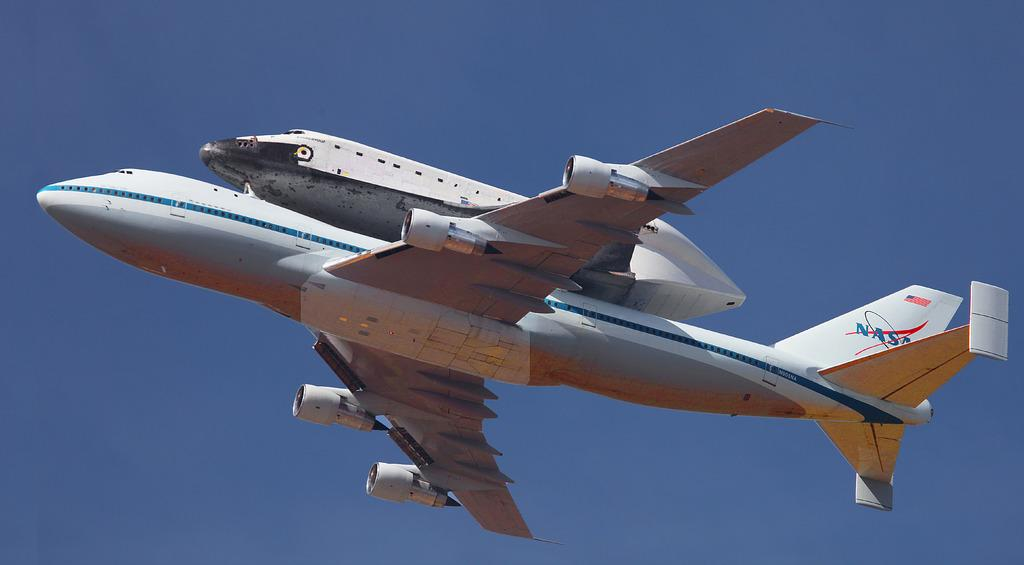What is the main subject of the picture? The main subject of the picture is an airplane. What is the airplane doing in the image? The airplane is flying in the air. What can be seen in the background of the image? The sky is visible in the background of the image. What is the color of the sky in the image? The color of the sky is blue. Can you see any nails being stretched by a hand in the image? No, there are no nails or hands present in the image; it features an airplane flying in the blue sky. 